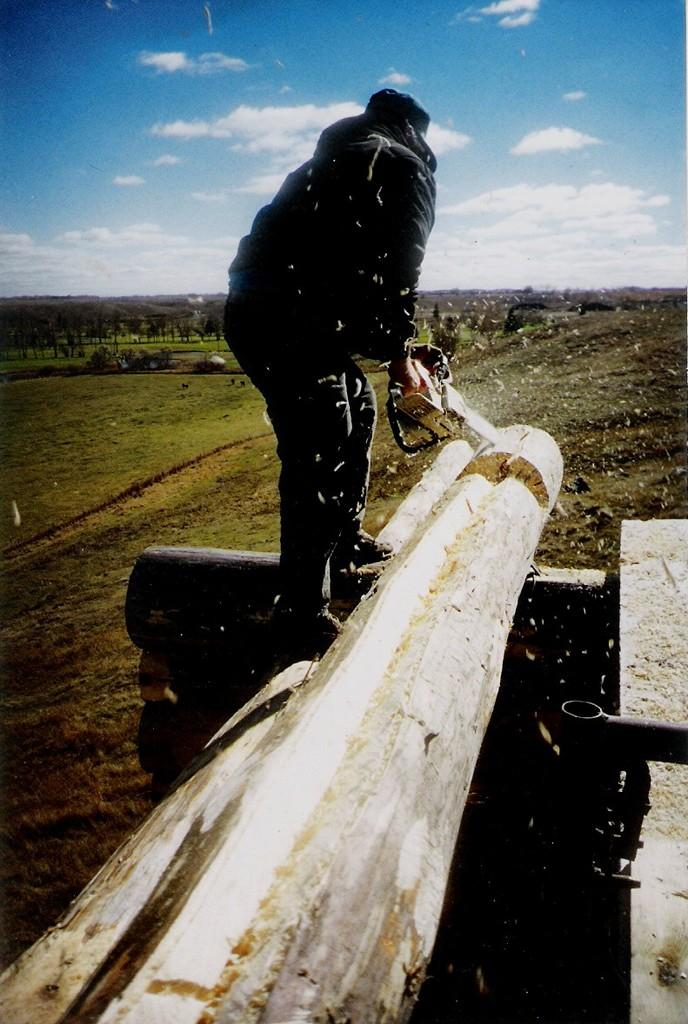What is the main subject of the image? There is a person in the center of the image. What is the person doing in the image? The person is sawing wood. What can be seen in the background of the image? There is grass, trees, plants, and the sky visible in the background of the image. What is the condition of the sky in the image? Clouds are present in the sky. What type of soup is being prepared in the image? There is no soup present in the image; the person is sawing wood. What tool is being used to cut the fabric in the image? There is no fabric or scissors present in the image; the person is sawing wood with a saw. 